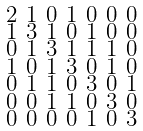Convert formula to latex. <formula><loc_0><loc_0><loc_500><loc_500>\begin{smallmatrix} 2 & 1 & 0 & 1 & 0 & 0 & 0 \\ 1 & 3 & 1 & 0 & 1 & 0 & 0 \\ 0 & 1 & 3 & 1 & 1 & 1 & 0 \\ 1 & 0 & 1 & 3 & 0 & 1 & 0 \\ 0 & 1 & 1 & 0 & 3 & 0 & 1 \\ 0 & 0 & 1 & 1 & 0 & 3 & 0 \\ 0 & 0 & 0 & 0 & 1 & 0 & 3 \end{smallmatrix}</formula> 